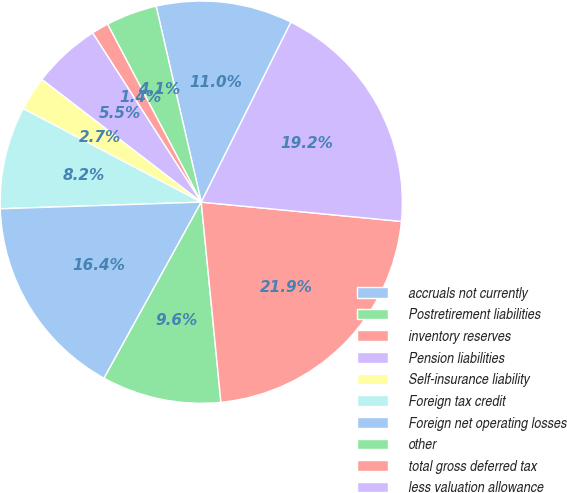Convert chart to OTSL. <chart><loc_0><loc_0><loc_500><loc_500><pie_chart><fcel>accruals not currently<fcel>Postretirement liabilities<fcel>inventory reserves<fcel>Pension liabilities<fcel>Self-insurance liability<fcel>Foreign tax credit<fcel>Foreign net operating losses<fcel>other<fcel>total gross deferred tax<fcel>less valuation allowance<nl><fcel>10.96%<fcel>4.11%<fcel>1.37%<fcel>5.48%<fcel>2.74%<fcel>8.22%<fcel>16.44%<fcel>9.59%<fcel>21.91%<fcel>19.17%<nl></chart> 